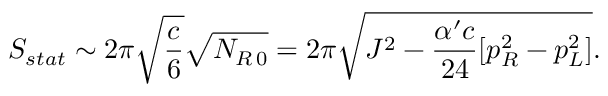<formula> <loc_0><loc_0><loc_500><loc_500>S _ { s t a t } \sim 2 \pi \sqrt { \frac { c } { 6 } } \sqrt { N _ { R \, 0 } } = 2 \pi \sqrt { J ^ { 2 } - { \frac { \alpha ^ { \prime } c } { 2 4 } } [ p _ { R } ^ { 2 } - p _ { L } ^ { 2 } ] } .</formula> 